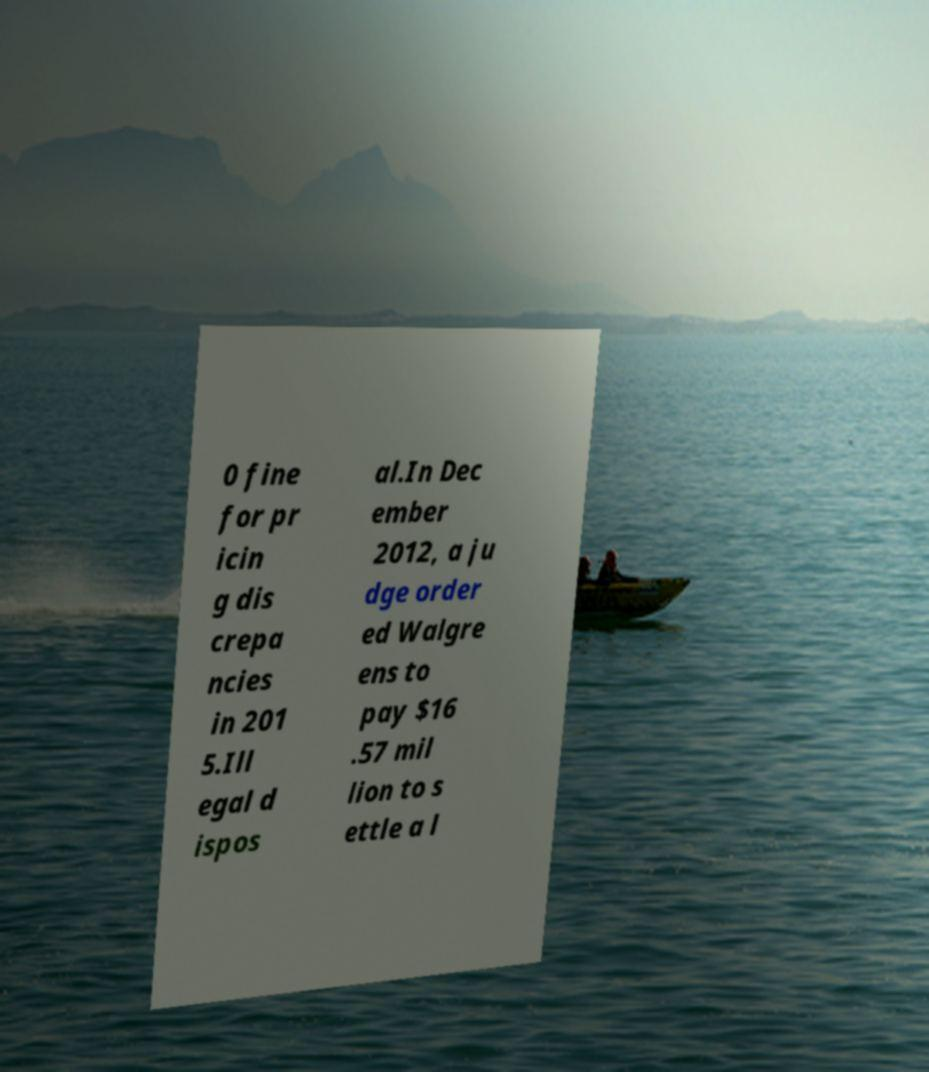Could you extract and type out the text from this image? 0 fine for pr icin g dis crepa ncies in 201 5.Ill egal d ispos al.In Dec ember 2012, a ju dge order ed Walgre ens to pay $16 .57 mil lion to s ettle a l 